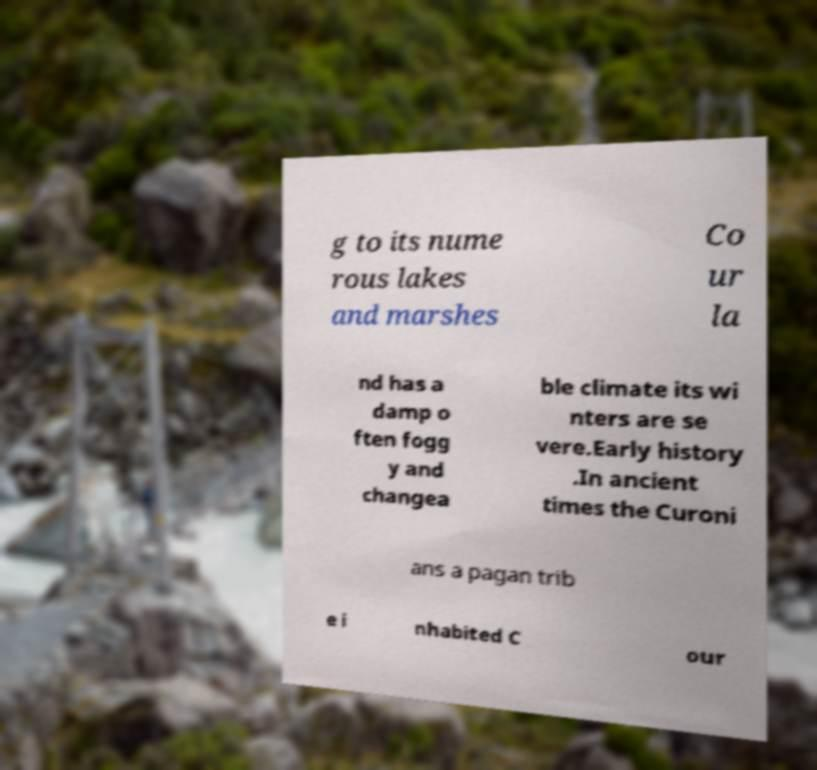Can you accurately transcribe the text from the provided image for me? g to its nume rous lakes and marshes Co ur la nd has a damp o ften fogg y and changea ble climate its wi nters are se vere.Early history .In ancient times the Curoni ans a pagan trib e i nhabited C our 